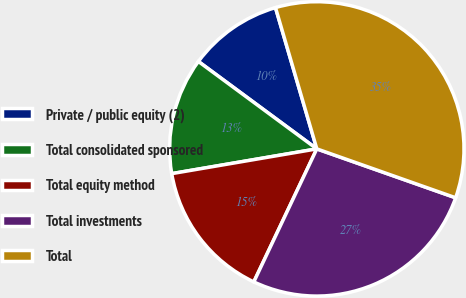Convert chart to OTSL. <chart><loc_0><loc_0><loc_500><loc_500><pie_chart><fcel>Private / public equity (2)<fcel>Total consolidated sponsored<fcel>Total equity method<fcel>Total investments<fcel>Total<nl><fcel>10.35%<fcel>12.81%<fcel>15.27%<fcel>26.65%<fcel>34.92%<nl></chart> 